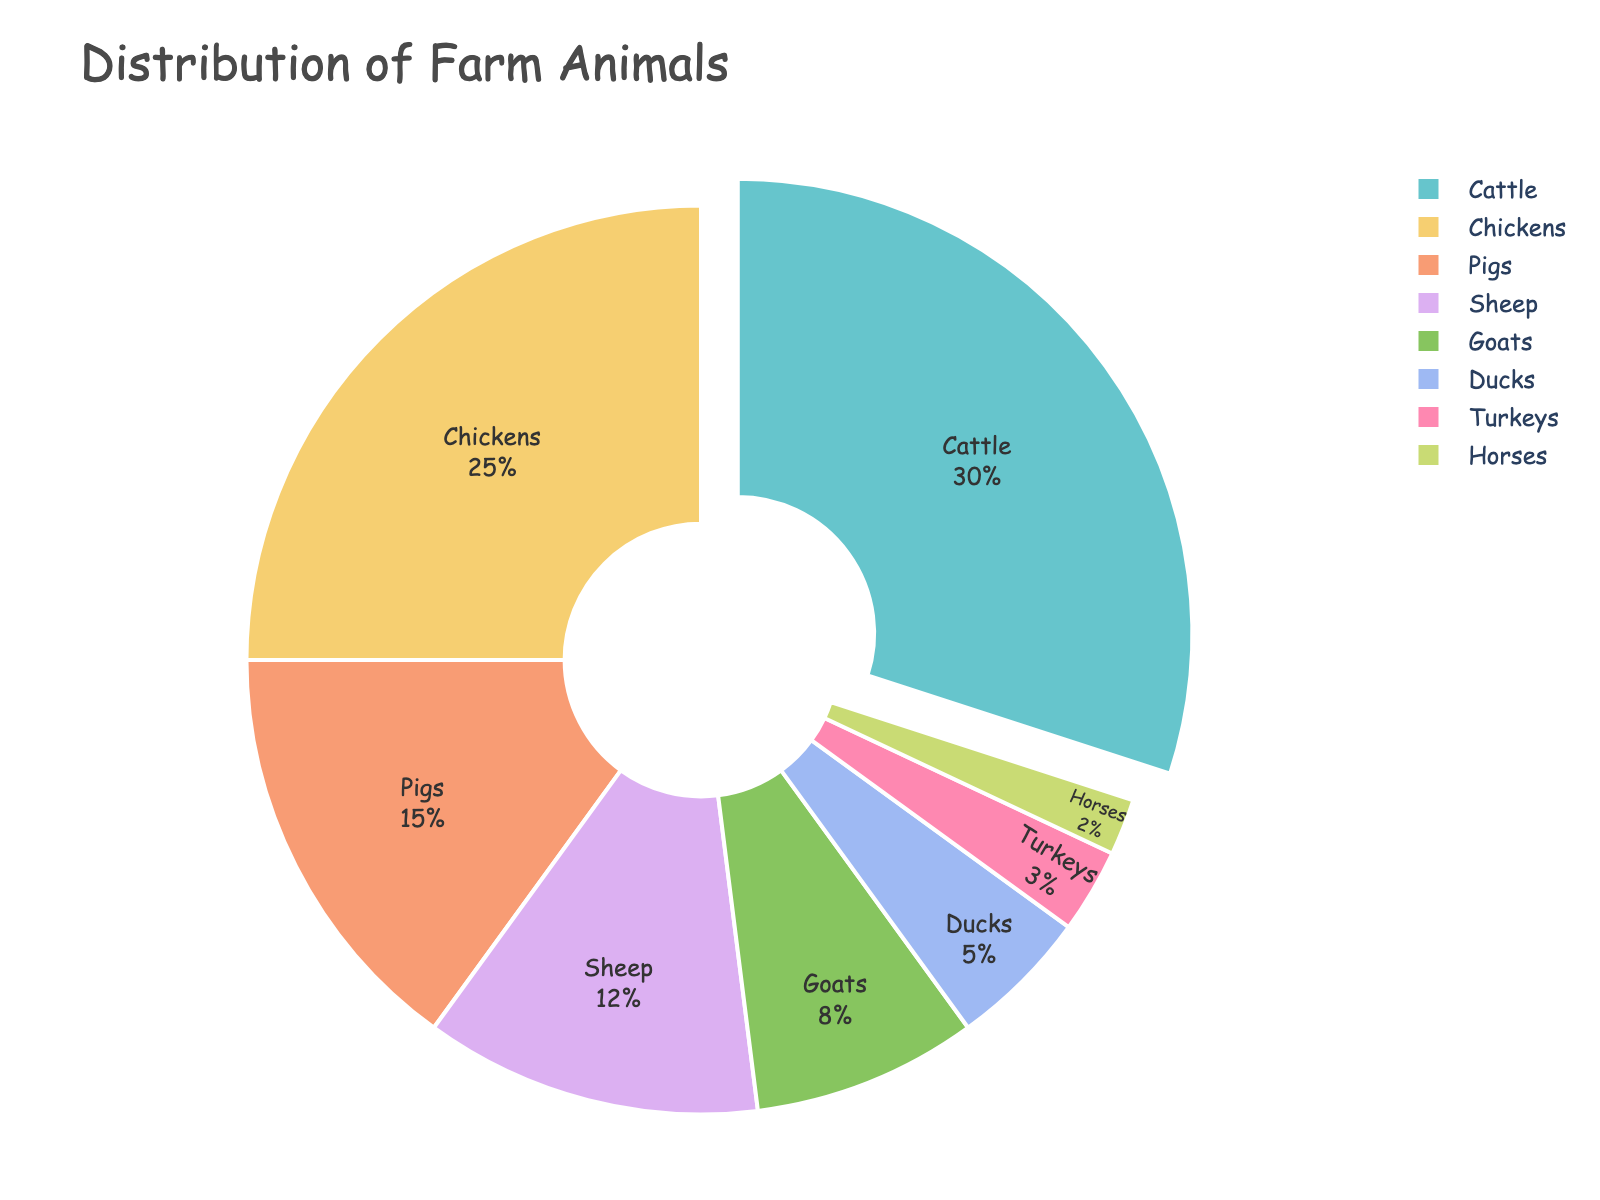what species of animal makes up the largest percentage on the farm? The largest section in the pie chart is labeled "Cattle," representing 30% of the total distribution.
Answer: Cattle which two species combined account for more animals than chickens? Cattle (30%) and pigs (15%) together account for 45%, which is more than chickens' 25%.
Answer: Cattle and pigs are there more chickens or sheep on the farm? Chickens are represented by 25%, while sheep account for 12%, so there are more chickens.
Answer: Chickens how many species make up less than 10% each of the total animals on the farm? Goats (8%), ducks (5%), turkeys (3%), and horses (2%) each represent less than 10%. That makes four species.
Answer: Four is the percentage of ducks greater or smaller than goats? Ducks account for 5%, whereas goats account for 8%. Thus, ducks have a smaller percentage.
Answer: Smaller what is the difference in percentage between the most and least prevalent species? The difference between cattle (30%) and horses (2%) is 30% - 2% = 28%.
Answer: 28% which species is represented by the smallest section of the pie chart? The smallest section is labeled "Horses," representing 2% of the total distribution.
Answer: Horses by what factor is the percentage of chickens greater than the percentage of turkeys? Chickens are 25%, and turkeys are 3%. The factor is 25/3 ≈ 8.33.
Answer: Approximately 8.33 if you combine the percentages of all poultry (chickens, ducks, turkeys), what is the total? Chickens (25%) + ducks (5%) + turkeys (3%) = 33%.
Answer: 33% which species is shown with a portion pulled out from the pie chart, and why? The cattle section is pulled out, possibly to highlight it as having the largest percentage.
Answer: Cattle 